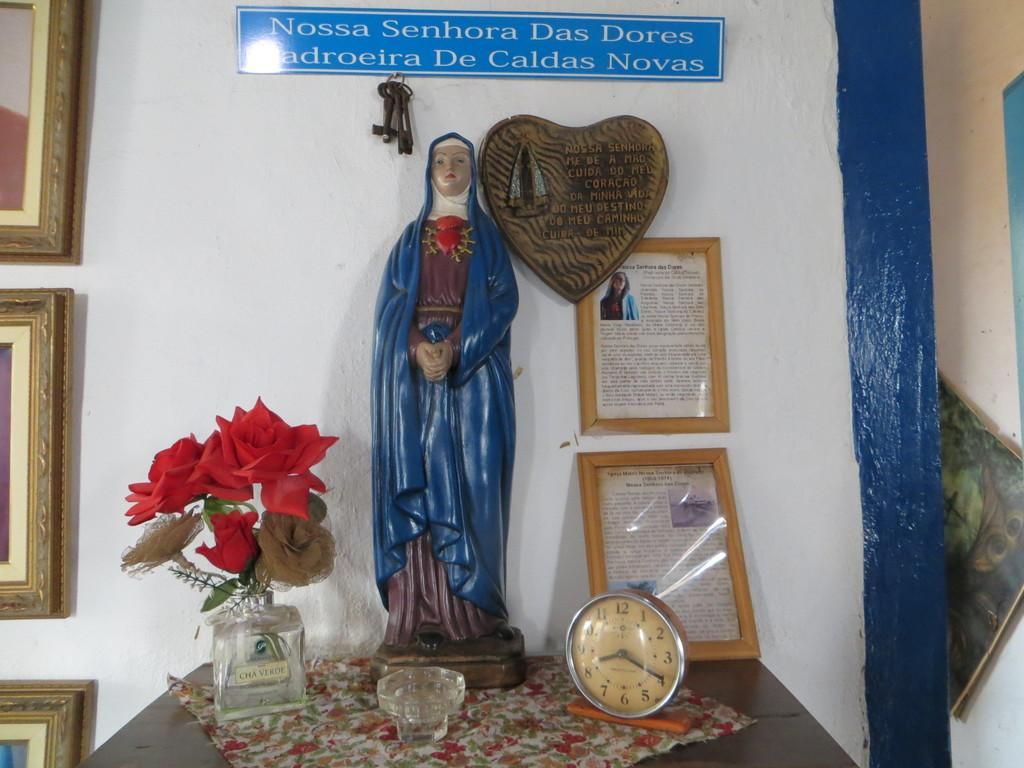Provide a one-sentence caption for the provided image. A religious statue with a clock that reads 8:20. 